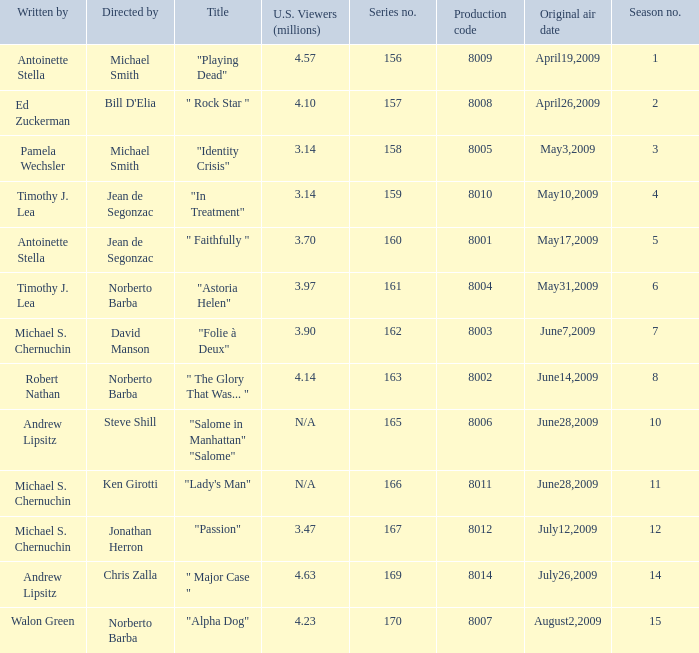What is the name of the episode whose writer is timothy j. lea and the director is norberto barba? "Astoria Helen". 